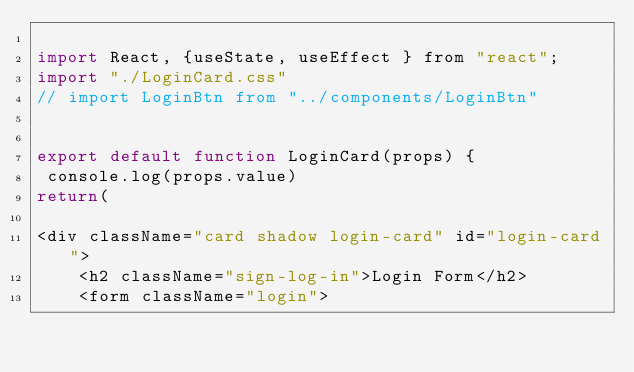Convert code to text. <code><loc_0><loc_0><loc_500><loc_500><_JavaScript_>
import React, {useState, useEffect } from "react";
import "./LoginCard.css"
// import LoginBtn from "../components/LoginBtn"


export default function LoginCard(props) {
 console.log(props.value)
return(

<div className="card shadow login-card" id="login-card">
    <h2 className="sign-log-in">Login Form</h2>
    <form className="login"></code> 